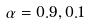<formula> <loc_0><loc_0><loc_500><loc_500>\alpha = 0 . 9 , 0 . 1</formula> 